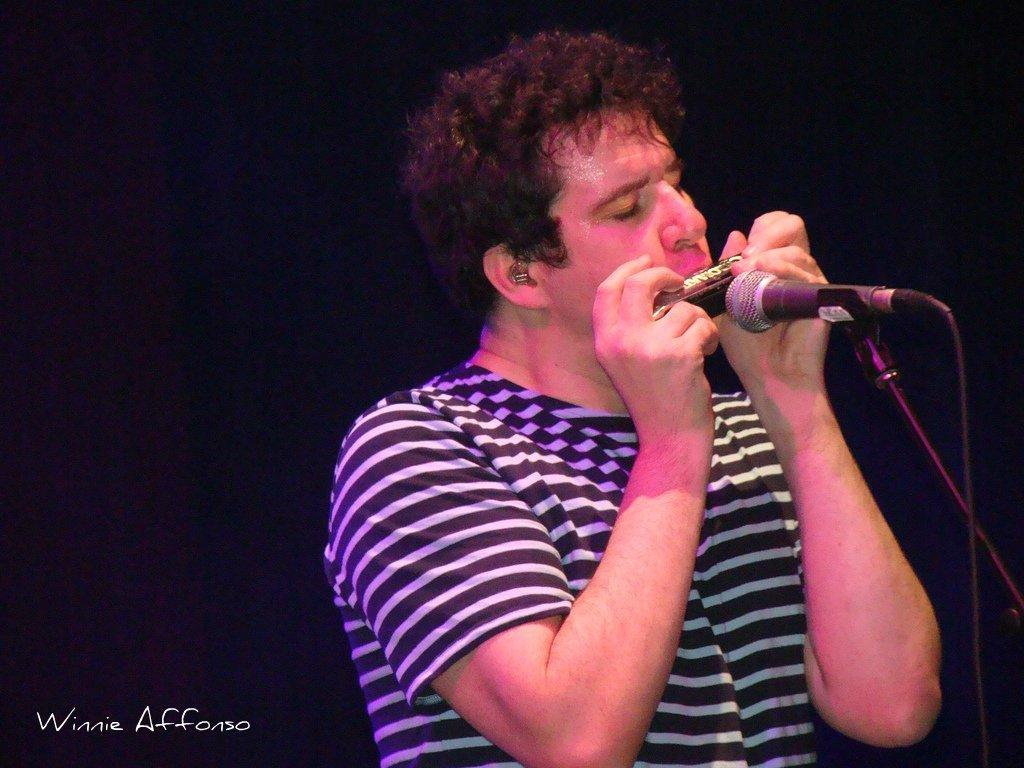What is the person in the image doing? The person is playing a mouth organ. What is in front of the person? There is a microphone and a microphone stand in front of the person. Can you describe the watermark in the image? There is a watermark in the left corner of the image. What is the color of the background in the image? The background of the image is dark. What is the queen doing in the image? There is no queen present in the image. What is the person learning in the image? The image does not show the person learning anything. 